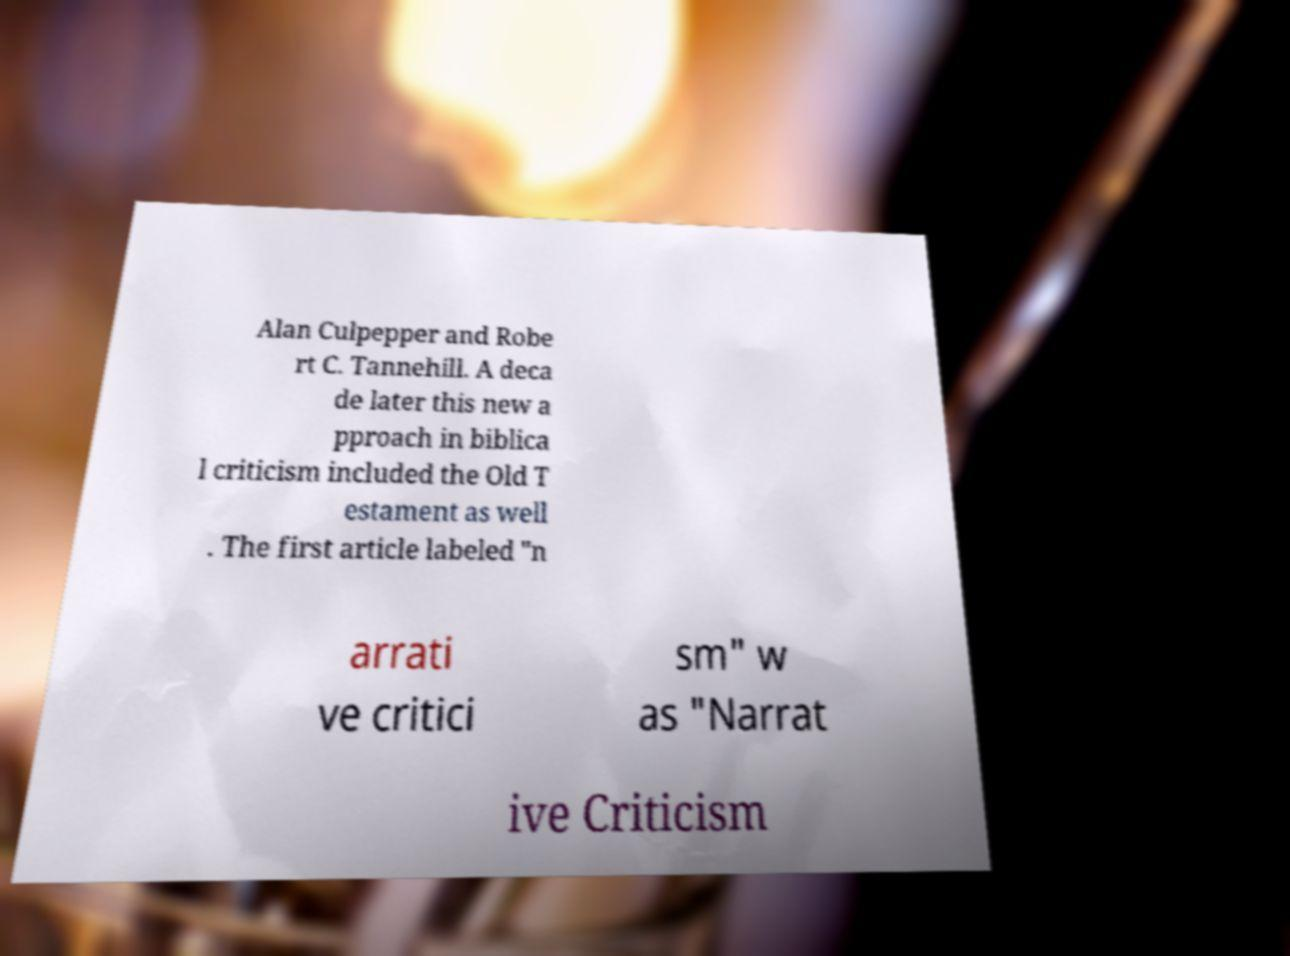Can you read and provide the text displayed in the image?This photo seems to have some interesting text. Can you extract and type it out for me? Alan Culpepper and Robe rt C. Tannehill. A deca de later this new a pproach in biblica l criticism included the Old T estament as well . The first article labeled "n arrati ve critici sm" w as "Narrat ive Criticism 